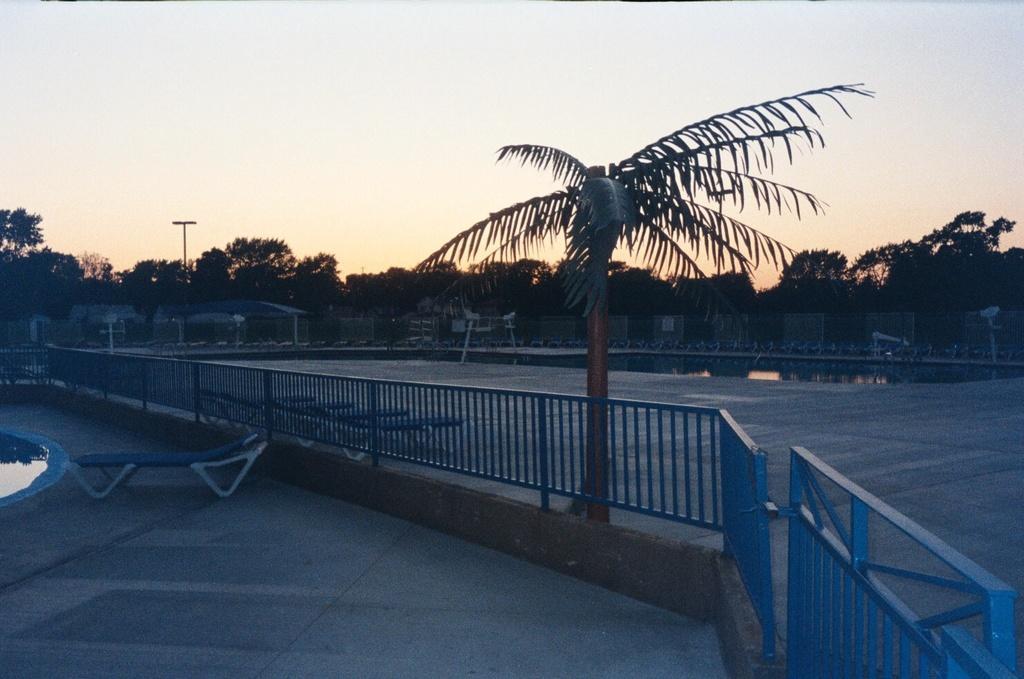Can you describe this image briefly? In this image we can see a fence, tree and other objects. In the background of the image there are trees, poles, shelter, water and other objects. At the top of the image there is the sky. At the bottom of the image there is the floor. On the left side of the image there is water. 